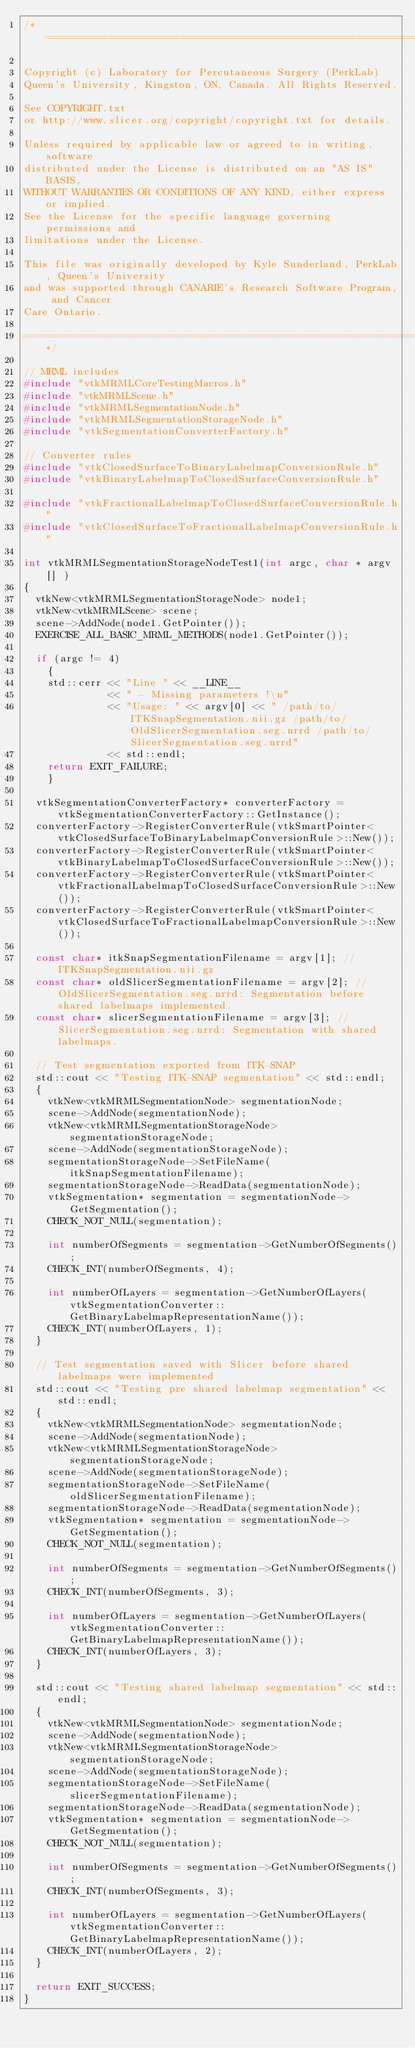Convert code to text. <code><loc_0><loc_0><loc_500><loc_500><_C++_>/*==============================================================================

Copyright (c) Laboratory for Percutaneous Surgery (PerkLab)
Queen's University, Kingston, ON, Canada. All Rights Reserved.

See COPYRIGHT.txt
or http://www.slicer.org/copyright/copyright.txt for details.

Unless required by applicable law or agreed to in writing, software
distributed under the License is distributed on an "AS IS" BASIS,
WITHOUT WARRANTIES OR CONDITIONS OF ANY KIND, either express or implied.
See the License for the specific language governing permissions and
limitations under the License.

This file was originally developed by Kyle Sunderland, PerkLab, Queen's University
and was supported through CANARIE's Research Software Program, and Cancer
Care Ontario.

==============================================================================*/

// MRML includes
#include "vtkMRMLCoreTestingMacros.h"
#include "vtkMRMLScene.h"
#include "vtkMRMLSegmentationNode.h"
#include "vtkMRMLSegmentationStorageNode.h"
#include "vtkSegmentationConverterFactory.h"

// Converter rules
#include "vtkClosedSurfaceToBinaryLabelmapConversionRule.h"
#include "vtkBinaryLabelmapToClosedSurfaceConversionRule.h"

#include "vtkFractionalLabelmapToClosedSurfaceConversionRule.h"
#include "vtkClosedSurfaceToFractionalLabelmapConversionRule.h"

int vtkMRMLSegmentationStorageNodeTest1(int argc, char * argv[] )
{
  vtkNew<vtkMRMLSegmentationStorageNode> node1;
  vtkNew<vtkMRMLScene> scene;
  scene->AddNode(node1.GetPointer());
  EXERCISE_ALL_BASIC_MRML_METHODS(node1.GetPointer());

  if (argc != 4)
    {
    std::cerr << "Line " << __LINE__
              << " - Missing parameters !\n"
              << "Usage: " << argv[0] << " /path/to/ITKSnapSegmentation.nii.gz /path/to/OldSlicerSegmentation.seg.nrrd /path/to/SlicerSegmentation.seg.nrrd"
              << std::endl;
    return EXIT_FAILURE;
    }

  vtkSegmentationConverterFactory* converterFactory = vtkSegmentationConverterFactory::GetInstance();
  converterFactory->RegisterConverterRule(vtkSmartPointer<vtkClosedSurfaceToBinaryLabelmapConversionRule>::New());
  converterFactory->RegisterConverterRule(vtkSmartPointer<vtkBinaryLabelmapToClosedSurfaceConversionRule>::New());
  converterFactory->RegisterConverterRule(vtkSmartPointer<vtkFractionalLabelmapToClosedSurfaceConversionRule>::New());
  converterFactory->RegisterConverterRule(vtkSmartPointer<vtkClosedSurfaceToFractionalLabelmapConversionRule>::New());

  const char* itkSnapSegmentationFilename = argv[1]; // ITKSnapSegmentation.nii.gz
  const char* oldSlicerSegmentationFilename = argv[2]; // OldSlicerSegmentation.seg.nrrd: Segmentation before shared labelmaps implemented.
  const char* slicerSegmentationFilename = argv[3]; // SlicerSegmentation.seg.nrrd: Segmentation with shared labelmaps.

  // Test segmentation exported from ITK-SNAP
  std::cout << "Testing ITK-SNAP segmentation" << std::endl;
  {
    vtkNew<vtkMRMLSegmentationNode> segmentationNode;
    scene->AddNode(segmentationNode);
    vtkNew<vtkMRMLSegmentationStorageNode> segmentationStorageNode;
    scene->AddNode(segmentationStorageNode);
    segmentationStorageNode->SetFileName(itkSnapSegmentationFilename);
    segmentationStorageNode->ReadData(segmentationNode);
    vtkSegmentation* segmentation = segmentationNode->GetSegmentation();
    CHECK_NOT_NULL(segmentation);

    int numberOfSegments = segmentation->GetNumberOfSegments();
    CHECK_INT(numberOfSegments, 4);

    int numberOfLayers = segmentation->GetNumberOfLayers(vtkSegmentationConverter::GetBinaryLabelmapRepresentationName());
    CHECK_INT(numberOfLayers, 1);
  }

  // Test segmentation saved with Slicer before shared labelmaps were implemented
  std::cout << "Testing pre shared labelmap segmentation" << std::endl;
  {
    vtkNew<vtkMRMLSegmentationNode> segmentationNode;
    scene->AddNode(segmentationNode);
    vtkNew<vtkMRMLSegmentationStorageNode> segmentationStorageNode;
    scene->AddNode(segmentationStorageNode);
    segmentationStorageNode->SetFileName(oldSlicerSegmentationFilename);
    segmentationStorageNode->ReadData(segmentationNode);
    vtkSegmentation* segmentation = segmentationNode->GetSegmentation();
    CHECK_NOT_NULL(segmentation);

    int numberOfSegments = segmentation->GetNumberOfSegments();
    CHECK_INT(numberOfSegments, 3);

    int numberOfLayers = segmentation->GetNumberOfLayers(vtkSegmentationConverter::GetBinaryLabelmapRepresentationName());
    CHECK_INT(numberOfLayers, 3);
  }

  std::cout << "Testing shared labelmap segmentation" << std::endl;
  {
    vtkNew<vtkMRMLSegmentationNode> segmentationNode;
    scene->AddNode(segmentationNode);
    vtkNew<vtkMRMLSegmentationStorageNode> segmentationStorageNode;
    scene->AddNode(segmentationStorageNode);
    segmentationStorageNode->SetFileName(slicerSegmentationFilename);
    segmentationStorageNode->ReadData(segmentationNode);
    vtkSegmentation* segmentation = segmentationNode->GetSegmentation();
    CHECK_NOT_NULL(segmentation);

    int numberOfSegments = segmentation->GetNumberOfSegments();
    CHECK_INT(numberOfSegments, 3);

    int numberOfLayers = segmentation->GetNumberOfLayers(vtkSegmentationConverter::GetBinaryLabelmapRepresentationName());
    CHECK_INT(numberOfLayers, 2);
  }

  return EXIT_SUCCESS;
}
</code> 